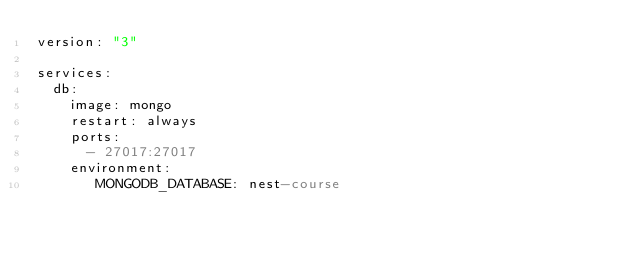<code> <loc_0><loc_0><loc_500><loc_500><_YAML_>version: "3"

services:
  db:
    image: mongo
    restart: always 
    ports:
      - 27017:27017
    environment:
       MONGODB_DATABASE: nest-course</code> 